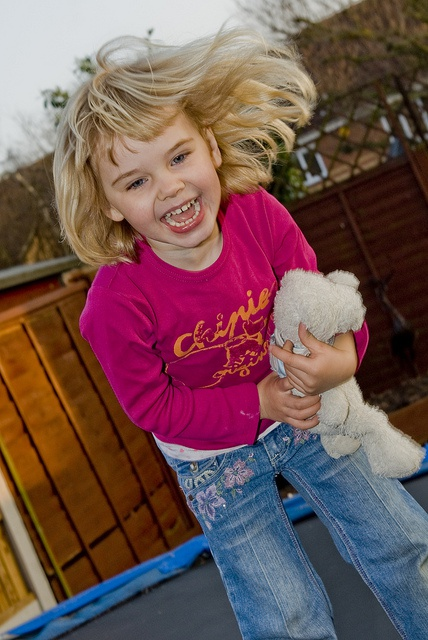Describe the objects in this image and their specific colors. I can see people in lightgray, purple, darkgray, tan, and gray tones and teddy bear in lightgray, darkgray, and gray tones in this image. 